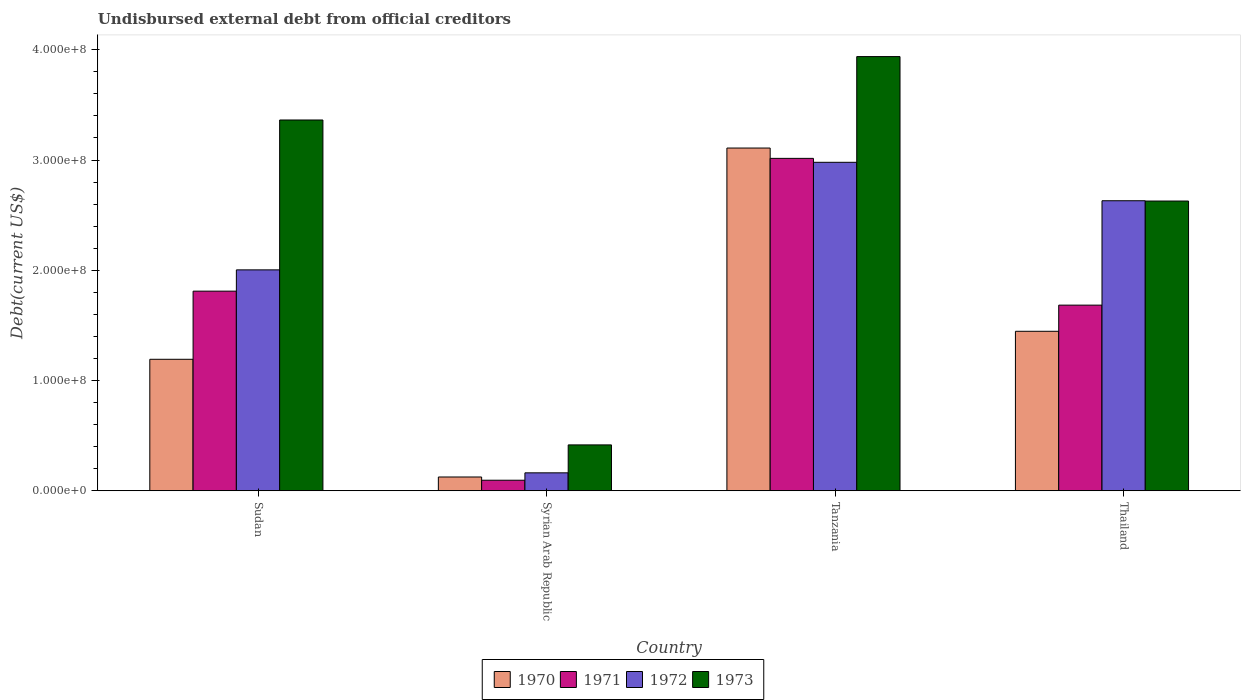How many different coloured bars are there?
Give a very brief answer. 4. Are the number of bars per tick equal to the number of legend labels?
Offer a terse response. Yes. How many bars are there on the 2nd tick from the left?
Ensure brevity in your answer.  4. What is the label of the 2nd group of bars from the left?
Provide a short and direct response. Syrian Arab Republic. In how many cases, is the number of bars for a given country not equal to the number of legend labels?
Offer a terse response. 0. What is the total debt in 1970 in Syrian Arab Republic?
Your answer should be compact. 1.25e+07. Across all countries, what is the maximum total debt in 1971?
Provide a succinct answer. 3.02e+08. Across all countries, what is the minimum total debt in 1972?
Offer a very short reply. 1.63e+07. In which country was the total debt in 1971 maximum?
Make the answer very short. Tanzania. In which country was the total debt in 1973 minimum?
Give a very brief answer. Syrian Arab Republic. What is the total total debt in 1972 in the graph?
Keep it short and to the point. 7.78e+08. What is the difference between the total debt in 1973 in Tanzania and that in Thailand?
Offer a terse response. 1.31e+08. What is the difference between the total debt in 1971 in Thailand and the total debt in 1970 in Syrian Arab Republic?
Provide a short and direct response. 1.56e+08. What is the average total debt in 1972 per country?
Keep it short and to the point. 1.94e+08. What is the difference between the total debt of/in 1973 and total debt of/in 1972 in Tanzania?
Provide a succinct answer. 9.59e+07. What is the ratio of the total debt in 1972 in Tanzania to that in Thailand?
Your answer should be very brief. 1.13. Is the difference between the total debt in 1973 in Sudan and Tanzania greater than the difference between the total debt in 1972 in Sudan and Tanzania?
Offer a very short reply. Yes. What is the difference between the highest and the second highest total debt in 1970?
Give a very brief answer. 1.92e+08. What is the difference between the highest and the lowest total debt in 1972?
Offer a terse response. 2.82e+08. What does the 1st bar from the right in Thailand represents?
Your response must be concise. 1973. Is it the case that in every country, the sum of the total debt in 1973 and total debt in 1972 is greater than the total debt in 1970?
Keep it short and to the point. Yes. How many bars are there?
Offer a terse response. 16. How many countries are there in the graph?
Make the answer very short. 4. What is the difference between two consecutive major ticks on the Y-axis?
Ensure brevity in your answer.  1.00e+08. Does the graph contain any zero values?
Provide a short and direct response. No. How are the legend labels stacked?
Make the answer very short. Horizontal. What is the title of the graph?
Offer a very short reply. Undisbursed external debt from official creditors. What is the label or title of the X-axis?
Keep it short and to the point. Country. What is the label or title of the Y-axis?
Your answer should be compact. Debt(current US$). What is the Debt(current US$) of 1970 in Sudan?
Offer a terse response. 1.19e+08. What is the Debt(current US$) of 1971 in Sudan?
Your response must be concise. 1.81e+08. What is the Debt(current US$) of 1972 in Sudan?
Provide a succinct answer. 2.00e+08. What is the Debt(current US$) in 1973 in Sudan?
Your response must be concise. 3.36e+08. What is the Debt(current US$) in 1970 in Syrian Arab Republic?
Provide a succinct answer. 1.25e+07. What is the Debt(current US$) in 1971 in Syrian Arab Republic?
Provide a succinct answer. 9.58e+06. What is the Debt(current US$) of 1972 in Syrian Arab Republic?
Keep it short and to the point. 1.63e+07. What is the Debt(current US$) in 1973 in Syrian Arab Republic?
Provide a succinct answer. 4.16e+07. What is the Debt(current US$) in 1970 in Tanzania?
Give a very brief answer. 3.11e+08. What is the Debt(current US$) in 1971 in Tanzania?
Your answer should be very brief. 3.02e+08. What is the Debt(current US$) of 1972 in Tanzania?
Offer a terse response. 2.98e+08. What is the Debt(current US$) in 1973 in Tanzania?
Your answer should be very brief. 3.94e+08. What is the Debt(current US$) in 1970 in Thailand?
Your response must be concise. 1.45e+08. What is the Debt(current US$) in 1971 in Thailand?
Offer a very short reply. 1.68e+08. What is the Debt(current US$) in 1972 in Thailand?
Give a very brief answer. 2.63e+08. What is the Debt(current US$) in 1973 in Thailand?
Your response must be concise. 2.63e+08. Across all countries, what is the maximum Debt(current US$) of 1970?
Your answer should be compact. 3.11e+08. Across all countries, what is the maximum Debt(current US$) in 1971?
Your answer should be compact. 3.02e+08. Across all countries, what is the maximum Debt(current US$) of 1972?
Keep it short and to the point. 2.98e+08. Across all countries, what is the maximum Debt(current US$) in 1973?
Provide a short and direct response. 3.94e+08. Across all countries, what is the minimum Debt(current US$) in 1970?
Your answer should be compact. 1.25e+07. Across all countries, what is the minimum Debt(current US$) of 1971?
Offer a very short reply. 9.58e+06. Across all countries, what is the minimum Debt(current US$) in 1972?
Your response must be concise. 1.63e+07. Across all countries, what is the minimum Debt(current US$) in 1973?
Make the answer very short. 4.16e+07. What is the total Debt(current US$) of 1970 in the graph?
Provide a succinct answer. 5.87e+08. What is the total Debt(current US$) of 1971 in the graph?
Make the answer very short. 6.61e+08. What is the total Debt(current US$) in 1972 in the graph?
Offer a very short reply. 7.78e+08. What is the total Debt(current US$) in 1973 in the graph?
Your response must be concise. 1.03e+09. What is the difference between the Debt(current US$) of 1970 in Sudan and that in Syrian Arab Republic?
Make the answer very short. 1.07e+08. What is the difference between the Debt(current US$) of 1971 in Sudan and that in Syrian Arab Republic?
Make the answer very short. 1.72e+08. What is the difference between the Debt(current US$) of 1972 in Sudan and that in Syrian Arab Republic?
Make the answer very short. 1.84e+08. What is the difference between the Debt(current US$) of 1973 in Sudan and that in Syrian Arab Republic?
Give a very brief answer. 2.95e+08. What is the difference between the Debt(current US$) of 1970 in Sudan and that in Tanzania?
Keep it short and to the point. -1.92e+08. What is the difference between the Debt(current US$) in 1971 in Sudan and that in Tanzania?
Ensure brevity in your answer.  -1.20e+08. What is the difference between the Debt(current US$) in 1972 in Sudan and that in Tanzania?
Ensure brevity in your answer.  -9.76e+07. What is the difference between the Debt(current US$) of 1973 in Sudan and that in Tanzania?
Make the answer very short. -5.75e+07. What is the difference between the Debt(current US$) in 1970 in Sudan and that in Thailand?
Offer a terse response. -2.54e+07. What is the difference between the Debt(current US$) in 1971 in Sudan and that in Thailand?
Offer a very short reply. 1.27e+07. What is the difference between the Debt(current US$) in 1972 in Sudan and that in Thailand?
Your response must be concise. -6.27e+07. What is the difference between the Debt(current US$) of 1973 in Sudan and that in Thailand?
Your answer should be compact. 7.35e+07. What is the difference between the Debt(current US$) of 1970 in Syrian Arab Republic and that in Tanzania?
Provide a short and direct response. -2.98e+08. What is the difference between the Debt(current US$) of 1971 in Syrian Arab Republic and that in Tanzania?
Provide a succinct answer. -2.92e+08. What is the difference between the Debt(current US$) in 1972 in Syrian Arab Republic and that in Tanzania?
Your response must be concise. -2.82e+08. What is the difference between the Debt(current US$) in 1973 in Syrian Arab Republic and that in Tanzania?
Provide a short and direct response. -3.52e+08. What is the difference between the Debt(current US$) in 1970 in Syrian Arab Republic and that in Thailand?
Offer a terse response. -1.32e+08. What is the difference between the Debt(current US$) of 1971 in Syrian Arab Republic and that in Thailand?
Give a very brief answer. -1.59e+08. What is the difference between the Debt(current US$) of 1972 in Syrian Arab Republic and that in Thailand?
Provide a succinct answer. -2.47e+08. What is the difference between the Debt(current US$) in 1973 in Syrian Arab Republic and that in Thailand?
Your answer should be compact. -2.21e+08. What is the difference between the Debt(current US$) in 1970 in Tanzania and that in Thailand?
Offer a very short reply. 1.66e+08. What is the difference between the Debt(current US$) of 1971 in Tanzania and that in Thailand?
Keep it short and to the point. 1.33e+08. What is the difference between the Debt(current US$) of 1972 in Tanzania and that in Thailand?
Ensure brevity in your answer.  3.49e+07. What is the difference between the Debt(current US$) of 1973 in Tanzania and that in Thailand?
Give a very brief answer. 1.31e+08. What is the difference between the Debt(current US$) in 1970 in Sudan and the Debt(current US$) in 1971 in Syrian Arab Republic?
Your response must be concise. 1.10e+08. What is the difference between the Debt(current US$) in 1970 in Sudan and the Debt(current US$) in 1972 in Syrian Arab Republic?
Your answer should be very brief. 1.03e+08. What is the difference between the Debt(current US$) in 1970 in Sudan and the Debt(current US$) in 1973 in Syrian Arab Republic?
Your response must be concise. 7.77e+07. What is the difference between the Debt(current US$) in 1971 in Sudan and the Debt(current US$) in 1972 in Syrian Arab Republic?
Your response must be concise. 1.65e+08. What is the difference between the Debt(current US$) of 1971 in Sudan and the Debt(current US$) of 1973 in Syrian Arab Republic?
Your response must be concise. 1.39e+08. What is the difference between the Debt(current US$) in 1972 in Sudan and the Debt(current US$) in 1973 in Syrian Arab Republic?
Your response must be concise. 1.59e+08. What is the difference between the Debt(current US$) of 1970 in Sudan and the Debt(current US$) of 1971 in Tanzania?
Your answer should be compact. -1.82e+08. What is the difference between the Debt(current US$) of 1970 in Sudan and the Debt(current US$) of 1972 in Tanzania?
Offer a terse response. -1.79e+08. What is the difference between the Debt(current US$) in 1970 in Sudan and the Debt(current US$) in 1973 in Tanzania?
Give a very brief answer. -2.75e+08. What is the difference between the Debt(current US$) of 1971 in Sudan and the Debt(current US$) of 1972 in Tanzania?
Your answer should be very brief. -1.17e+08. What is the difference between the Debt(current US$) in 1971 in Sudan and the Debt(current US$) in 1973 in Tanzania?
Make the answer very short. -2.13e+08. What is the difference between the Debt(current US$) in 1972 in Sudan and the Debt(current US$) in 1973 in Tanzania?
Provide a succinct answer. -1.93e+08. What is the difference between the Debt(current US$) of 1970 in Sudan and the Debt(current US$) of 1971 in Thailand?
Provide a succinct answer. -4.91e+07. What is the difference between the Debt(current US$) in 1970 in Sudan and the Debt(current US$) in 1972 in Thailand?
Keep it short and to the point. -1.44e+08. What is the difference between the Debt(current US$) of 1970 in Sudan and the Debt(current US$) of 1973 in Thailand?
Provide a succinct answer. -1.44e+08. What is the difference between the Debt(current US$) of 1971 in Sudan and the Debt(current US$) of 1972 in Thailand?
Keep it short and to the point. -8.20e+07. What is the difference between the Debt(current US$) of 1971 in Sudan and the Debt(current US$) of 1973 in Thailand?
Make the answer very short. -8.17e+07. What is the difference between the Debt(current US$) of 1972 in Sudan and the Debt(current US$) of 1973 in Thailand?
Keep it short and to the point. -6.24e+07. What is the difference between the Debt(current US$) of 1970 in Syrian Arab Republic and the Debt(current US$) of 1971 in Tanzania?
Your answer should be very brief. -2.89e+08. What is the difference between the Debt(current US$) in 1970 in Syrian Arab Republic and the Debt(current US$) in 1972 in Tanzania?
Your answer should be very brief. -2.85e+08. What is the difference between the Debt(current US$) of 1970 in Syrian Arab Republic and the Debt(current US$) of 1973 in Tanzania?
Provide a short and direct response. -3.81e+08. What is the difference between the Debt(current US$) in 1971 in Syrian Arab Republic and the Debt(current US$) in 1972 in Tanzania?
Offer a terse response. -2.88e+08. What is the difference between the Debt(current US$) in 1971 in Syrian Arab Republic and the Debt(current US$) in 1973 in Tanzania?
Offer a terse response. -3.84e+08. What is the difference between the Debt(current US$) of 1972 in Syrian Arab Republic and the Debt(current US$) of 1973 in Tanzania?
Your response must be concise. -3.78e+08. What is the difference between the Debt(current US$) in 1970 in Syrian Arab Republic and the Debt(current US$) in 1971 in Thailand?
Offer a terse response. -1.56e+08. What is the difference between the Debt(current US$) in 1970 in Syrian Arab Republic and the Debt(current US$) in 1972 in Thailand?
Give a very brief answer. -2.51e+08. What is the difference between the Debt(current US$) of 1970 in Syrian Arab Republic and the Debt(current US$) of 1973 in Thailand?
Your answer should be very brief. -2.50e+08. What is the difference between the Debt(current US$) of 1971 in Syrian Arab Republic and the Debt(current US$) of 1972 in Thailand?
Provide a succinct answer. -2.54e+08. What is the difference between the Debt(current US$) in 1971 in Syrian Arab Republic and the Debt(current US$) in 1973 in Thailand?
Your answer should be compact. -2.53e+08. What is the difference between the Debt(current US$) of 1972 in Syrian Arab Republic and the Debt(current US$) of 1973 in Thailand?
Make the answer very short. -2.47e+08. What is the difference between the Debt(current US$) in 1970 in Tanzania and the Debt(current US$) in 1971 in Thailand?
Give a very brief answer. 1.42e+08. What is the difference between the Debt(current US$) of 1970 in Tanzania and the Debt(current US$) of 1972 in Thailand?
Keep it short and to the point. 4.78e+07. What is the difference between the Debt(current US$) of 1970 in Tanzania and the Debt(current US$) of 1973 in Thailand?
Keep it short and to the point. 4.81e+07. What is the difference between the Debt(current US$) of 1971 in Tanzania and the Debt(current US$) of 1972 in Thailand?
Your answer should be very brief. 3.84e+07. What is the difference between the Debt(current US$) in 1971 in Tanzania and the Debt(current US$) in 1973 in Thailand?
Your answer should be compact. 3.87e+07. What is the difference between the Debt(current US$) of 1972 in Tanzania and the Debt(current US$) of 1973 in Thailand?
Offer a very short reply. 3.51e+07. What is the average Debt(current US$) in 1970 per country?
Your answer should be compact. 1.47e+08. What is the average Debt(current US$) in 1971 per country?
Make the answer very short. 1.65e+08. What is the average Debt(current US$) in 1972 per country?
Your response must be concise. 1.94e+08. What is the average Debt(current US$) in 1973 per country?
Offer a terse response. 2.59e+08. What is the difference between the Debt(current US$) in 1970 and Debt(current US$) in 1971 in Sudan?
Provide a succinct answer. -6.18e+07. What is the difference between the Debt(current US$) of 1970 and Debt(current US$) of 1972 in Sudan?
Provide a succinct answer. -8.11e+07. What is the difference between the Debt(current US$) in 1970 and Debt(current US$) in 1973 in Sudan?
Offer a terse response. -2.17e+08. What is the difference between the Debt(current US$) of 1971 and Debt(current US$) of 1972 in Sudan?
Offer a terse response. -1.93e+07. What is the difference between the Debt(current US$) of 1971 and Debt(current US$) of 1973 in Sudan?
Offer a terse response. -1.55e+08. What is the difference between the Debt(current US$) of 1972 and Debt(current US$) of 1973 in Sudan?
Provide a succinct answer. -1.36e+08. What is the difference between the Debt(current US$) in 1970 and Debt(current US$) in 1971 in Syrian Arab Republic?
Your answer should be compact. 2.94e+06. What is the difference between the Debt(current US$) of 1970 and Debt(current US$) of 1972 in Syrian Arab Republic?
Keep it short and to the point. -3.78e+06. What is the difference between the Debt(current US$) of 1970 and Debt(current US$) of 1973 in Syrian Arab Republic?
Provide a short and direct response. -2.91e+07. What is the difference between the Debt(current US$) in 1971 and Debt(current US$) in 1972 in Syrian Arab Republic?
Keep it short and to the point. -6.71e+06. What is the difference between the Debt(current US$) of 1971 and Debt(current US$) of 1973 in Syrian Arab Republic?
Provide a succinct answer. -3.20e+07. What is the difference between the Debt(current US$) in 1972 and Debt(current US$) in 1973 in Syrian Arab Republic?
Your response must be concise. -2.53e+07. What is the difference between the Debt(current US$) of 1970 and Debt(current US$) of 1971 in Tanzania?
Give a very brief answer. 9.37e+06. What is the difference between the Debt(current US$) of 1970 and Debt(current US$) of 1972 in Tanzania?
Keep it short and to the point. 1.29e+07. What is the difference between the Debt(current US$) of 1970 and Debt(current US$) of 1973 in Tanzania?
Give a very brief answer. -8.30e+07. What is the difference between the Debt(current US$) of 1971 and Debt(current US$) of 1972 in Tanzania?
Keep it short and to the point. 3.57e+06. What is the difference between the Debt(current US$) in 1971 and Debt(current US$) in 1973 in Tanzania?
Offer a terse response. -9.23e+07. What is the difference between the Debt(current US$) in 1972 and Debt(current US$) in 1973 in Tanzania?
Provide a succinct answer. -9.59e+07. What is the difference between the Debt(current US$) in 1970 and Debt(current US$) in 1971 in Thailand?
Give a very brief answer. -2.37e+07. What is the difference between the Debt(current US$) in 1970 and Debt(current US$) in 1972 in Thailand?
Give a very brief answer. -1.18e+08. What is the difference between the Debt(current US$) in 1970 and Debt(current US$) in 1973 in Thailand?
Your answer should be compact. -1.18e+08. What is the difference between the Debt(current US$) of 1971 and Debt(current US$) of 1972 in Thailand?
Provide a succinct answer. -9.47e+07. What is the difference between the Debt(current US$) of 1971 and Debt(current US$) of 1973 in Thailand?
Your answer should be very brief. -9.44e+07. What is the difference between the Debt(current US$) of 1972 and Debt(current US$) of 1973 in Thailand?
Ensure brevity in your answer.  2.70e+05. What is the ratio of the Debt(current US$) of 1970 in Sudan to that in Syrian Arab Republic?
Give a very brief answer. 9.53. What is the ratio of the Debt(current US$) of 1971 in Sudan to that in Syrian Arab Republic?
Provide a succinct answer. 18.91. What is the ratio of the Debt(current US$) in 1972 in Sudan to that in Syrian Arab Republic?
Your answer should be compact. 12.3. What is the ratio of the Debt(current US$) in 1973 in Sudan to that in Syrian Arab Republic?
Your response must be concise. 8.08. What is the ratio of the Debt(current US$) in 1970 in Sudan to that in Tanzania?
Your answer should be very brief. 0.38. What is the ratio of the Debt(current US$) in 1971 in Sudan to that in Tanzania?
Make the answer very short. 0.6. What is the ratio of the Debt(current US$) of 1972 in Sudan to that in Tanzania?
Offer a terse response. 0.67. What is the ratio of the Debt(current US$) of 1973 in Sudan to that in Tanzania?
Make the answer very short. 0.85. What is the ratio of the Debt(current US$) of 1970 in Sudan to that in Thailand?
Provide a succinct answer. 0.82. What is the ratio of the Debt(current US$) in 1971 in Sudan to that in Thailand?
Your answer should be very brief. 1.08. What is the ratio of the Debt(current US$) in 1972 in Sudan to that in Thailand?
Provide a short and direct response. 0.76. What is the ratio of the Debt(current US$) in 1973 in Sudan to that in Thailand?
Offer a terse response. 1.28. What is the ratio of the Debt(current US$) in 1970 in Syrian Arab Republic to that in Tanzania?
Your answer should be compact. 0.04. What is the ratio of the Debt(current US$) of 1971 in Syrian Arab Republic to that in Tanzania?
Keep it short and to the point. 0.03. What is the ratio of the Debt(current US$) of 1972 in Syrian Arab Republic to that in Tanzania?
Make the answer very short. 0.05. What is the ratio of the Debt(current US$) in 1973 in Syrian Arab Republic to that in Tanzania?
Give a very brief answer. 0.11. What is the ratio of the Debt(current US$) in 1970 in Syrian Arab Republic to that in Thailand?
Your answer should be compact. 0.09. What is the ratio of the Debt(current US$) of 1971 in Syrian Arab Republic to that in Thailand?
Ensure brevity in your answer.  0.06. What is the ratio of the Debt(current US$) in 1972 in Syrian Arab Republic to that in Thailand?
Offer a very short reply. 0.06. What is the ratio of the Debt(current US$) in 1973 in Syrian Arab Republic to that in Thailand?
Give a very brief answer. 0.16. What is the ratio of the Debt(current US$) in 1970 in Tanzania to that in Thailand?
Your answer should be compact. 2.15. What is the ratio of the Debt(current US$) of 1971 in Tanzania to that in Thailand?
Offer a very short reply. 1.79. What is the ratio of the Debt(current US$) in 1972 in Tanzania to that in Thailand?
Give a very brief answer. 1.13. What is the ratio of the Debt(current US$) in 1973 in Tanzania to that in Thailand?
Provide a short and direct response. 1.5. What is the difference between the highest and the second highest Debt(current US$) of 1970?
Your answer should be compact. 1.66e+08. What is the difference between the highest and the second highest Debt(current US$) of 1971?
Give a very brief answer. 1.20e+08. What is the difference between the highest and the second highest Debt(current US$) in 1972?
Offer a very short reply. 3.49e+07. What is the difference between the highest and the second highest Debt(current US$) of 1973?
Your answer should be very brief. 5.75e+07. What is the difference between the highest and the lowest Debt(current US$) in 1970?
Keep it short and to the point. 2.98e+08. What is the difference between the highest and the lowest Debt(current US$) in 1971?
Provide a succinct answer. 2.92e+08. What is the difference between the highest and the lowest Debt(current US$) of 1972?
Your response must be concise. 2.82e+08. What is the difference between the highest and the lowest Debt(current US$) of 1973?
Your answer should be very brief. 3.52e+08. 